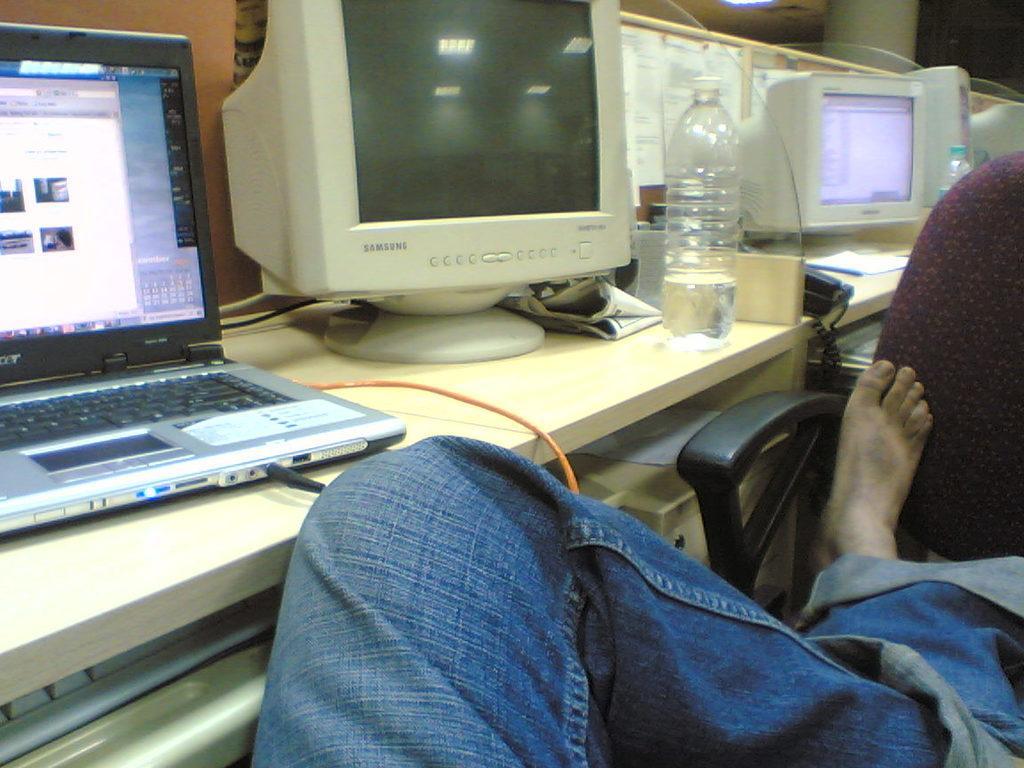Could you give a brief overview of what you see in this image? This is a person leg on this chair. On this table there is a monitor, bottle, posters and laptop. 